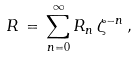<formula> <loc_0><loc_0><loc_500><loc_500>R \, = \, \sum _ { n = 0 } ^ { \infty } R _ { n } \, \zeta ^ { - n } \, ,</formula> 